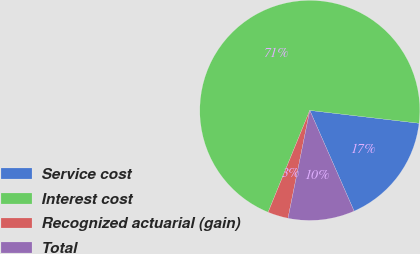Convert chart to OTSL. <chart><loc_0><loc_0><loc_500><loc_500><pie_chart><fcel>Service cost<fcel>Interest cost<fcel>Recognized actuarial (gain)<fcel>Total<nl><fcel>16.54%<fcel>70.68%<fcel>3.01%<fcel>9.77%<nl></chart> 